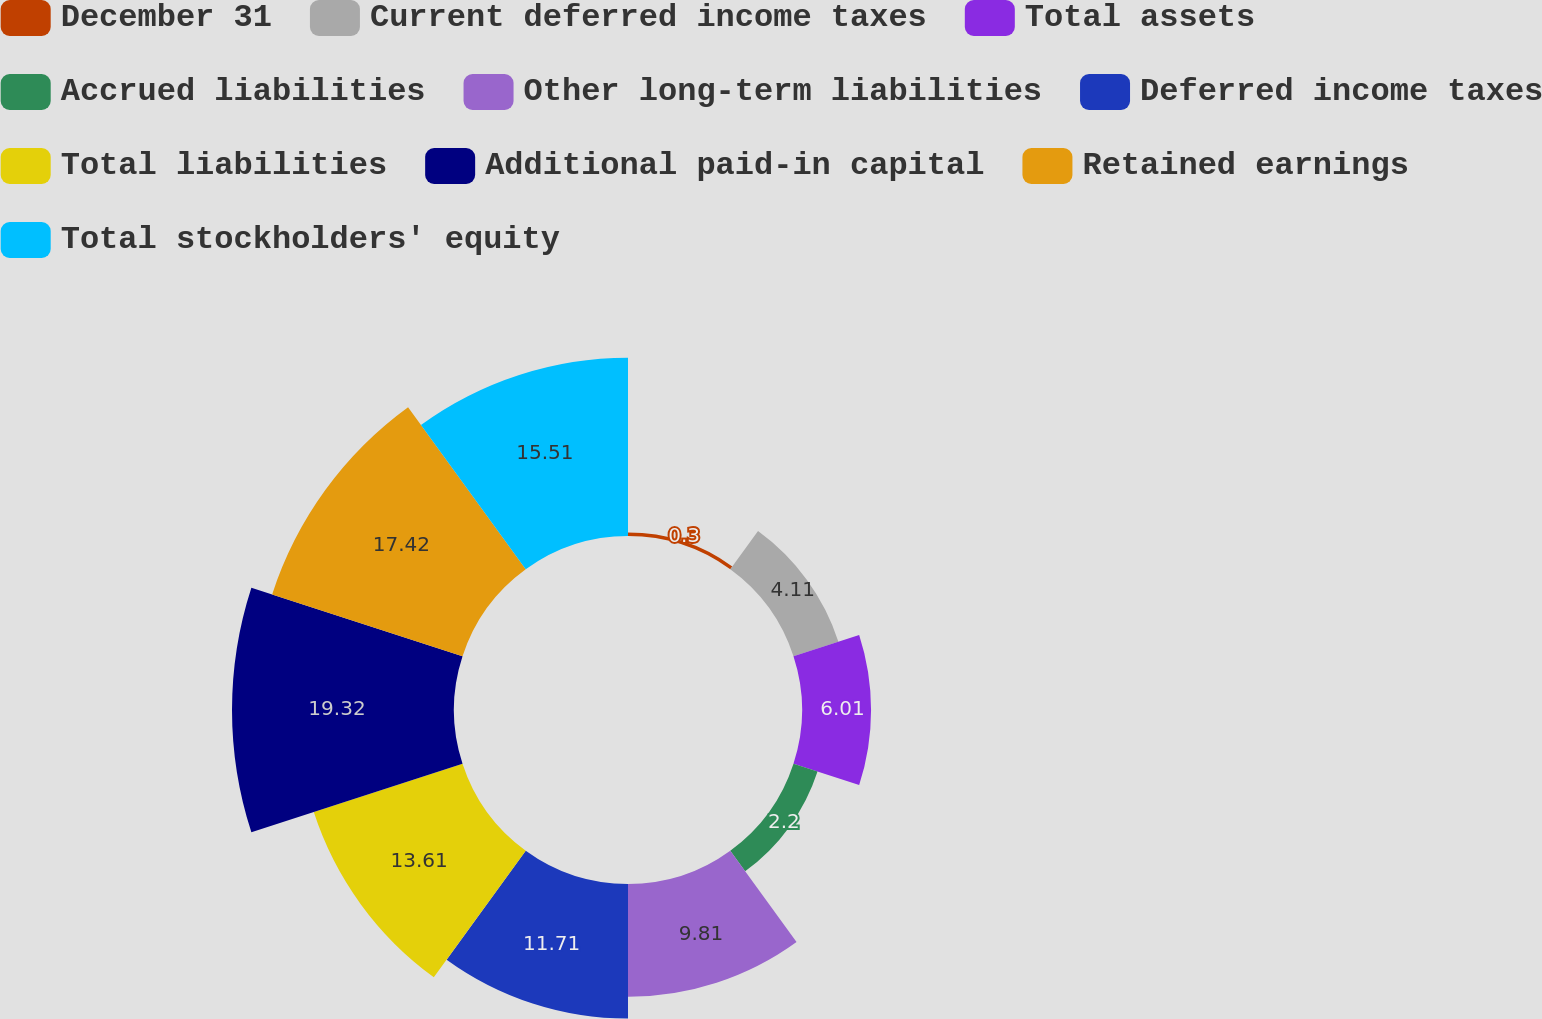<chart> <loc_0><loc_0><loc_500><loc_500><pie_chart><fcel>December 31<fcel>Current deferred income taxes<fcel>Total assets<fcel>Accrued liabilities<fcel>Other long-term liabilities<fcel>Deferred income taxes<fcel>Total liabilities<fcel>Additional paid-in capital<fcel>Retained earnings<fcel>Total stockholders' equity<nl><fcel>0.3%<fcel>4.11%<fcel>6.01%<fcel>2.2%<fcel>9.81%<fcel>11.71%<fcel>13.61%<fcel>19.32%<fcel>17.42%<fcel>15.51%<nl></chart> 